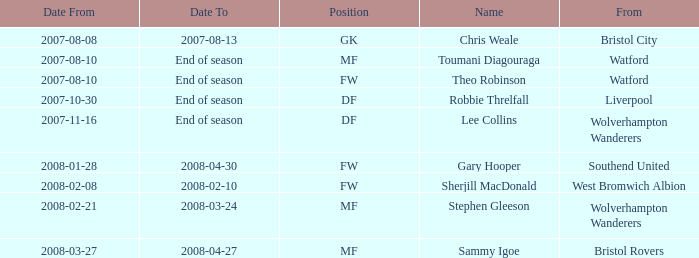From which place was the df-positioned player, who commenced on 2007-10-30, hailing? Liverpool. 